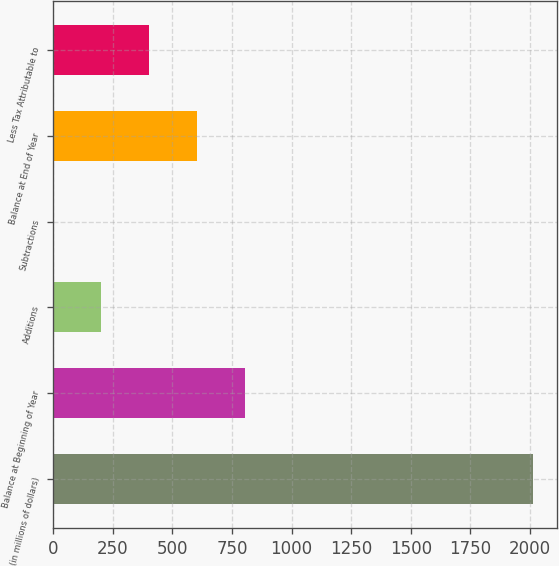Convert chart. <chart><loc_0><loc_0><loc_500><loc_500><bar_chart><fcel>(in millions of dollars)<fcel>Balance at Beginning of Year<fcel>Additions<fcel>Subtractions<fcel>Balance at End of Year<fcel>Less Tax Attributable to<nl><fcel>2012<fcel>805.16<fcel>201.74<fcel>0.6<fcel>604.02<fcel>402.88<nl></chart> 